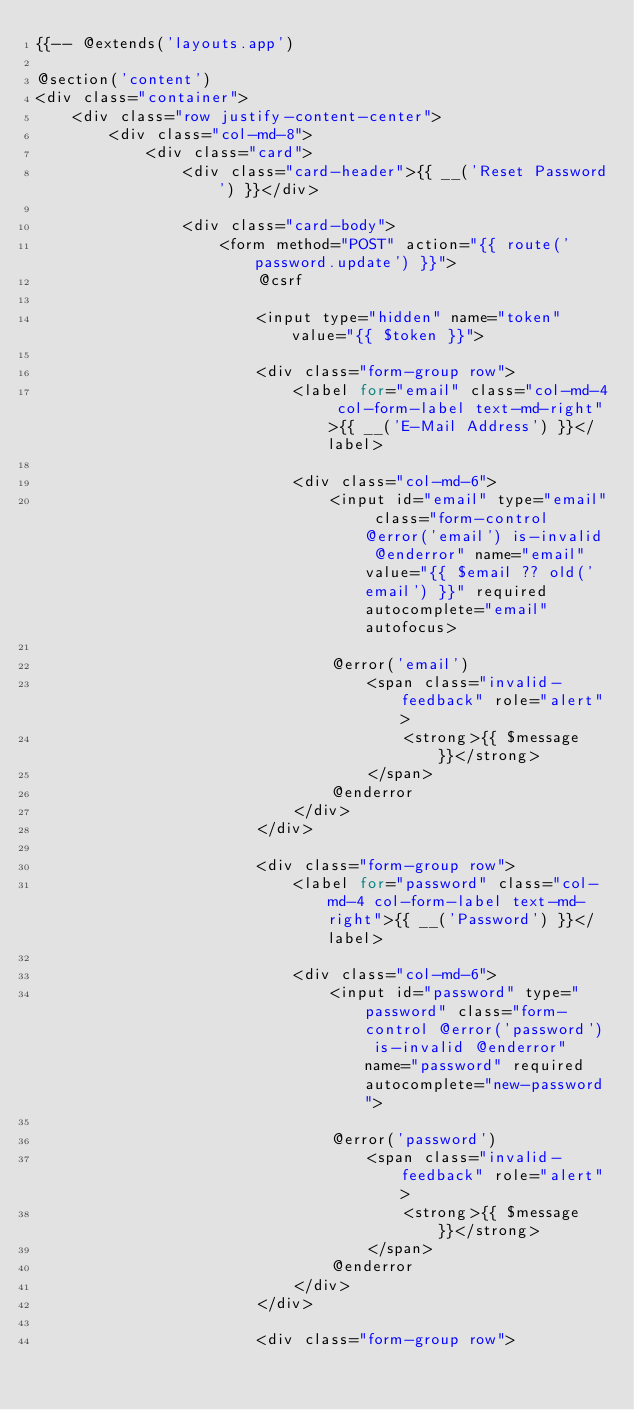<code> <loc_0><loc_0><loc_500><loc_500><_PHP_>{{-- @extends('layouts.app')

@section('content')
<div class="container">
    <div class="row justify-content-center">
        <div class="col-md-8">
            <div class="card">
                <div class="card-header">{{ __('Reset Password') }}</div>

                <div class="card-body">
                    <form method="POST" action="{{ route('password.update') }}">
                        @csrf

                        <input type="hidden" name="token" value="{{ $token }}">

                        <div class="form-group row">
                            <label for="email" class="col-md-4 col-form-label text-md-right">{{ __('E-Mail Address') }}</label>

                            <div class="col-md-6">
                                <input id="email" type="email" class="form-control @error('email') is-invalid @enderror" name="email" value="{{ $email ?? old('email') }}" required autocomplete="email" autofocus>

                                @error('email')
                                    <span class="invalid-feedback" role="alert">
                                        <strong>{{ $message }}</strong>
                                    </span>
                                @enderror
                            </div>
                        </div>

                        <div class="form-group row">
                            <label for="password" class="col-md-4 col-form-label text-md-right">{{ __('Password') }}</label>

                            <div class="col-md-6">
                                <input id="password" type="password" class="form-control @error('password') is-invalid @enderror" name="password" required autocomplete="new-password">

                                @error('password')
                                    <span class="invalid-feedback" role="alert">
                                        <strong>{{ $message }}</strong>
                                    </span>
                                @enderror
                            </div>
                        </div>

                        <div class="form-group row"></code> 